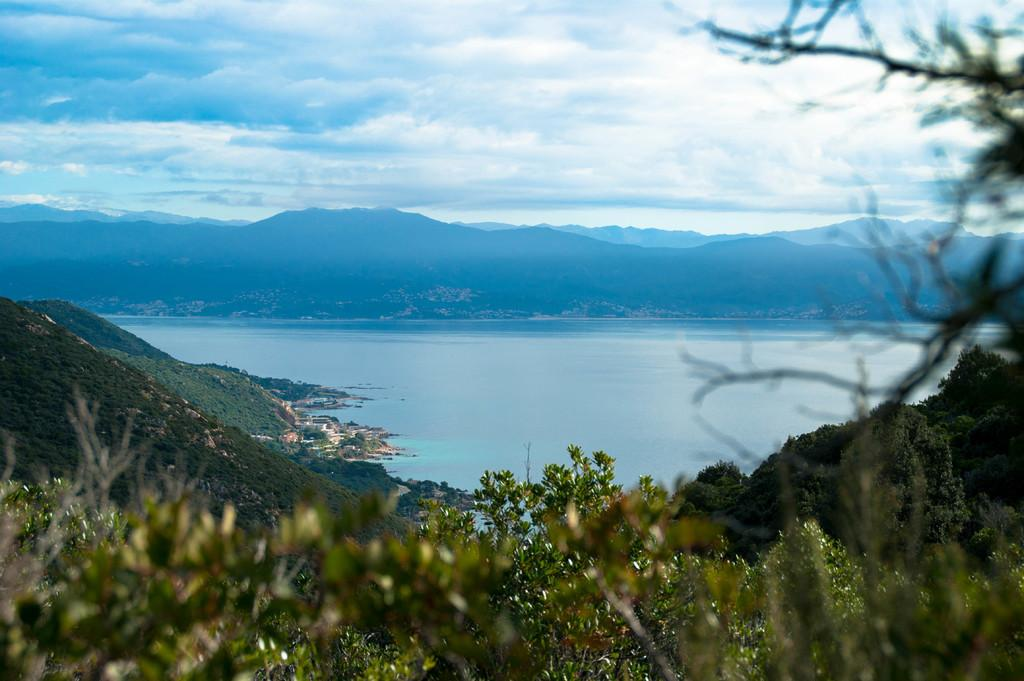What type of living organisms can be seen in the image? Plants can be seen in the image. How are the plants arranged in the image? The plants are arranged from left to right. What else can be seen in the image besides the plants? Water is visible in the image. What is visible in the background of the image? Mountains and a cloudy sky can be seen in the background of the image. Can you tell me how many baby yaks are grazing near the plants in the image? There are no yaks, baby or otherwise, present in the image. The image only features plants, water, mountains, and a cloudy sky. 